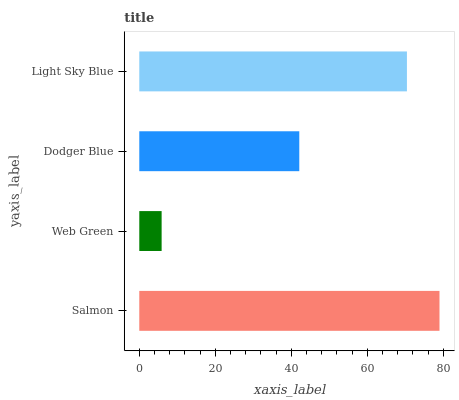Is Web Green the minimum?
Answer yes or no. Yes. Is Salmon the maximum?
Answer yes or no. Yes. Is Dodger Blue the minimum?
Answer yes or no. No. Is Dodger Blue the maximum?
Answer yes or no. No. Is Dodger Blue greater than Web Green?
Answer yes or no. Yes. Is Web Green less than Dodger Blue?
Answer yes or no. Yes. Is Web Green greater than Dodger Blue?
Answer yes or no. No. Is Dodger Blue less than Web Green?
Answer yes or no. No. Is Light Sky Blue the high median?
Answer yes or no. Yes. Is Dodger Blue the low median?
Answer yes or no. Yes. Is Web Green the high median?
Answer yes or no. No. Is Light Sky Blue the low median?
Answer yes or no. No. 